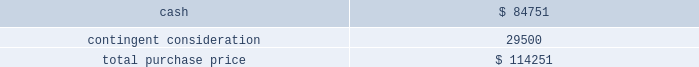Table of contents the company concluded that the acquisition of sentinelle medical did not represent a material business combination , and therefore , no pro forma financial information has been provided herein .
Subsequent to the acquisition date , the company 2019s results of operations include the results of sentinelle medical , which is included within the company 2019s breast health reporting segment .
The company accounted for the sentinelle medical acquisition as a purchase of a business under asc 805 .
The purchase price was comprised of an $ 84.8 million cash payment , which was net of certain adjustments , plus three contingent payments up to a maximum of an additional $ 250.0 million in cash .
The contingent payments are based on a multiple of incremental revenue growth during the two-year period following the completion of the acquisition as follows : six months after acquisition , 12 months after acquisition , and 24 months after acquisition .
Pursuant to asc 805 , the company recorded its estimate of the fair value of the contingent consideration liability based on future revenue projections of the sentinelle medical business under various potential scenarios and weighted probability assumptions of these outcomes .
As of the date of acquisition , these cash flow projections were discounted using a rate of 16.5% ( 16.5 % ) .
The discount rate is based on the weighted-average cost of capital of the acquired business plus a credit risk premium for non-performance risk related to the liability pursuant to asc 820 .
This analysis resulted in an initial contingent consideration liability of $ 29.5 million , which will be adjusted periodically as a component of operating expenses based on changes in the fair value of the liability driven by the accretion of the liability for the time value of money and changes in the assumptions pertaining to the achievement of the defined revenue growth milestones .
This fair value measurement was based on significant inputs not observable in the market and thus represented a level 3 measurement as defined in asc during each quarter in fiscal 2011 , the company has re-evaluated its assumptions and updated the revenue and probability assumptions for future earn-out periods and lowered its projections .
As a result of these adjustments , which were partially offset by the accretion of the liability , and using a current discount rate of approximately 17.0% ( 17.0 % ) , the company recorded a reversal of expense of $ 14.3 million in fiscal 2011 to record the contingent consideration liability at fair value .
In addition , during the second quarter of fiscal 2011 , the first earn-out period ended , and the company adjusted the fair value of the contingent consideration liability for actual results during the earn-out period .
This payment of $ 4.3 million was made in the third quarter of fiscal 2011 .
At september 24 , 2011 , the fair value of the liability is $ 10.9 million .
The company did not issue any equity awards in connection with this acquisition .
The company incurred third-party transaction costs of $ 1.2 million , which were expensed within general and administrative expenses in fiscal 2010 .
The purchase price was as follows: .
Source : hologic inc , 10-k , november 23 , 2011 powered by morningstar ae document research 2120 the information contained herein may not be copied , adapted or distributed and is not warranted to be accurate , complete or timely .
The user assumes all risks for any damages or losses arising from any use of this information , except to the extent such damages or losses cannot be limited or excluded by applicable law .
Past financial performance is no guarantee of future results. .
What portion of the sentinelle medical's purchase price is related to contingent consideration? 
Computations: (29500 / 114251)
Answer: 0.2582. 